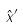<formula> <loc_0><loc_0><loc_500><loc_500>\hat { x } ^ { \prime }</formula> 